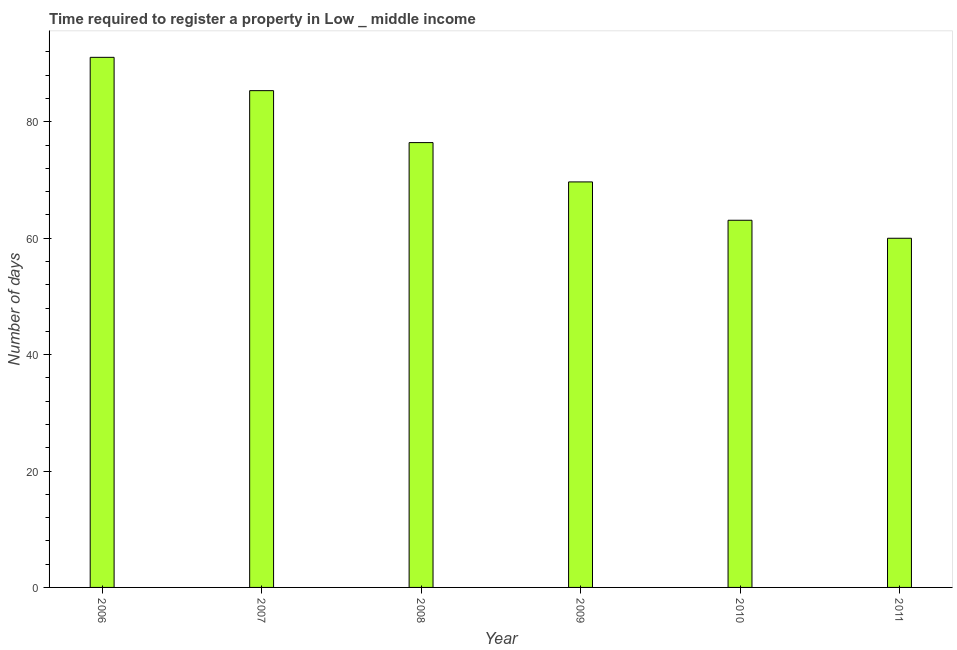Does the graph contain any zero values?
Provide a succinct answer. No. Does the graph contain grids?
Provide a short and direct response. No. What is the title of the graph?
Ensure brevity in your answer.  Time required to register a property in Low _ middle income. What is the label or title of the X-axis?
Offer a terse response. Year. What is the label or title of the Y-axis?
Ensure brevity in your answer.  Number of days. What is the number of days required to register property in 2009?
Make the answer very short. 69.67. Across all years, what is the maximum number of days required to register property?
Make the answer very short. 91.08. Across all years, what is the minimum number of days required to register property?
Make the answer very short. 59.99. In which year was the number of days required to register property maximum?
Ensure brevity in your answer.  2006. In which year was the number of days required to register property minimum?
Provide a short and direct response. 2011. What is the sum of the number of days required to register property?
Provide a succinct answer. 445.59. What is the difference between the number of days required to register property in 2008 and 2010?
Your answer should be compact. 13.34. What is the average number of days required to register property per year?
Keep it short and to the point. 74.27. What is the median number of days required to register property?
Your response must be concise. 73.05. In how many years, is the number of days required to register property greater than 36 days?
Ensure brevity in your answer.  6. What is the ratio of the number of days required to register property in 2009 to that in 2010?
Ensure brevity in your answer.  1.1. Is the number of days required to register property in 2006 less than that in 2009?
Offer a very short reply. No. What is the difference between the highest and the second highest number of days required to register property?
Provide a short and direct response. 5.73. Is the sum of the number of days required to register property in 2007 and 2009 greater than the maximum number of days required to register property across all years?
Offer a terse response. Yes. What is the difference between the highest and the lowest number of days required to register property?
Ensure brevity in your answer.  31.08. In how many years, is the number of days required to register property greater than the average number of days required to register property taken over all years?
Provide a short and direct response. 3. How many bars are there?
Ensure brevity in your answer.  6. Are all the bars in the graph horizontal?
Provide a short and direct response. No. How many years are there in the graph?
Give a very brief answer. 6. What is the difference between two consecutive major ticks on the Y-axis?
Your answer should be very brief. 20. Are the values on the major ticks of Y-axis written in scientific E-notation?
Give a very brief answer. No. What is the Number of days of 2006?
Make the answer very short. 91.08. What is the Number of days in 2007?
Keep it short and to the point. 85.35. What is the Number of days in 2008?
Your answer should be compact. 76.42. What is the Number of days in 2009?
Provide a short and direct response. 69.67. What is the Number of days of 2010?
Provide a short and direct response. 63.08. What is the Number of days in 2011?
Provide a succinct answer. 59.99. What is the difference between the Number of days in 2006 and 2007?
Provide a succinct answer. 5.73. What is the difference between the Number of days in 2006 and 2008?
Keep it short and to the point. 14.65. What is the difference between the Number of days in 2006 and 2009?
Your response must be concise. 21.4. What is the difference between the Number of days in 2006 and 2010?
Provide a succinct answer. 27.99. What is the difference between the Number of days in 2006 and 2011?
Make the answer very short. 31.08. What is the difference between the Number of days in 2007 and 2008?
Your response must be concise. 8.92. What is the difference between the Number of days in 2007 and 2009?
Offer a very short reply. 15.68. What is the difference between the Number of days in 2007 and 2010?
Your answer should be compact. 22.27. What is the difference between the Number of days in 2007 and 2011?
Your answer should be compact. 25.36. What is the difference between the Number of days in 2008 and 2009?
Ensure brevity in your answer.  6.75. What is the difference between the Number of days in 2008 and 2010?
Make the answer very short. 13.34. What is the difference between the Number of days in 2008 and 2011?
Your answer should be compact. 16.43. What is the difference between the Number of days in 2009 and 2010?
Your answer should be compact. 6.59. What is the difference between the Number of days in 2009 and 2011?
Provide a succinct answer. 9.68. What is the difference between the Number of days in 2010 and 2011?
Your answer should be compact. 3.09. What is the ratio of the Number of days in 2006 to that in 2007?
Your answer should be compact. 1.07. What is the ratio of the Number of days in 2006 to that in 2008?
Your answer should be very brief. 1.19. What is the ratio of the Number of days in 2006 to that in 2009?
Your response must be concise. 1.31. What is the ratio of the Number of days in 2006 to that in 2010?
Offer a very short reply. 1.44. What is the ratio of the Number of days in 2006 to that in 2011?
Provide a succinct answer. 1.52. What is the ratio of the Number of days in 2007 to that in 2008?
Provide a short and direct response. 1.12. What is the ratio of the Number of days in 2007 to that in 2009?
Provide a succinct answer. 1.23. What is the ratio of the Number of days in 2007 to that in 2010?
Your response must be concise. 1.35. What is the ratio of the Number of days in 2007 to that in 2011?
Your response must be concise. 1.42. What is the ratio of the Number of days in 2008 to that in 2009?
Keep it short and to the point. 1.1. What is the ratio of the Number of days in 2008 to that in 2010?
Make the answer very short. 1.21. What is the ratio of the Number of days in 2008 to that in 2011?
Your answer should be compact. 1.27. What is the ratio of the Number of days in 2009 to that in 2010?
Your answer should be compact. 1.1. What is the ratio of the Number of days in 2009 to that in 2011?
Your answer should be very brief. 1.16. What is the ratio of the Number of days in 2010 to that in 2011?
Provide a short and direct response. 1.05. 